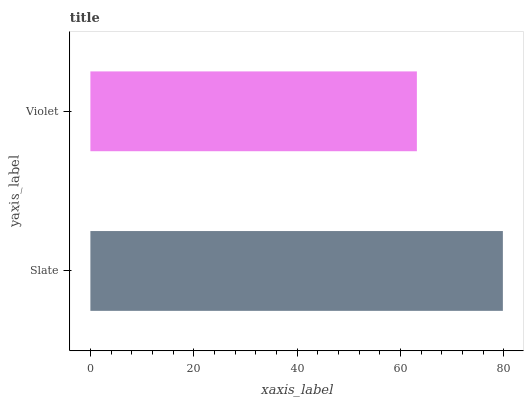Is Violet the minimum?
Answer yes or no. Yes. Is Slate the maximum?
Answer yes or no. Yes. Is Violet the maximum?
Answer yes or no. No. Is Slate greater than Violet?
Answer yes or no. Yes. Is Violet less than Slate?
Answer yes or no. Yes. Is Violet greater than Slate?
Answer yes or no. No. Is Slate less than Violet?
Answer yes or no. No. Is Slate the high median?
Answer yes or no. Yes. Is Violet the low median?
Answer yes or no. Yes. Is Violet the high median?
Answer yes or no. No. Is Slate the low median?
Answer yes or no. No. 